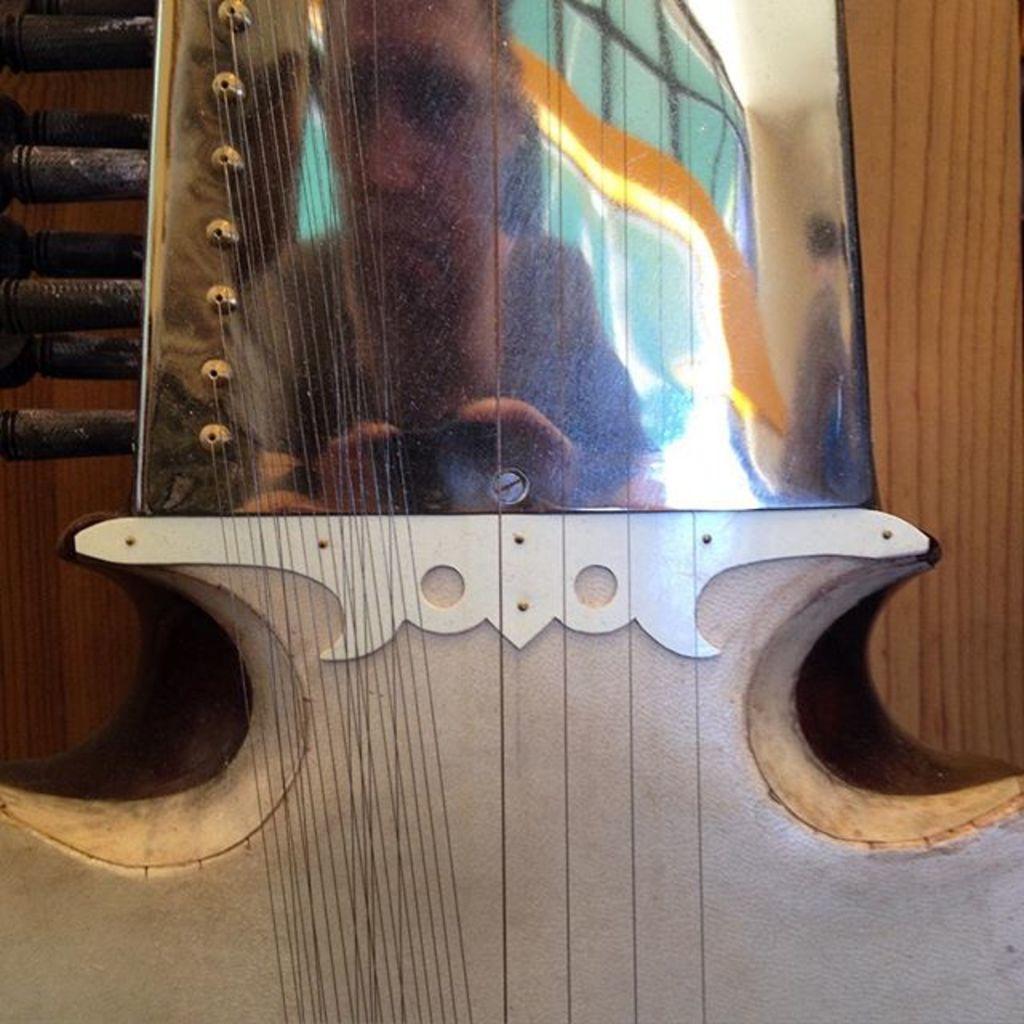Can you describe this image briefly? In this picture there is a musical instrument. There are strings attached to it. In the reflection there is a person. In the background there is wall. 